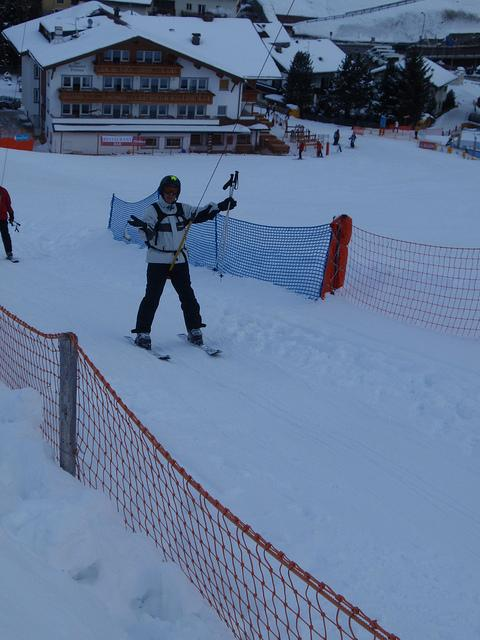What's the name of the large white building in the background?

Choices:
A) hotel
B) lodge
C) terminal
D) casino lodge 